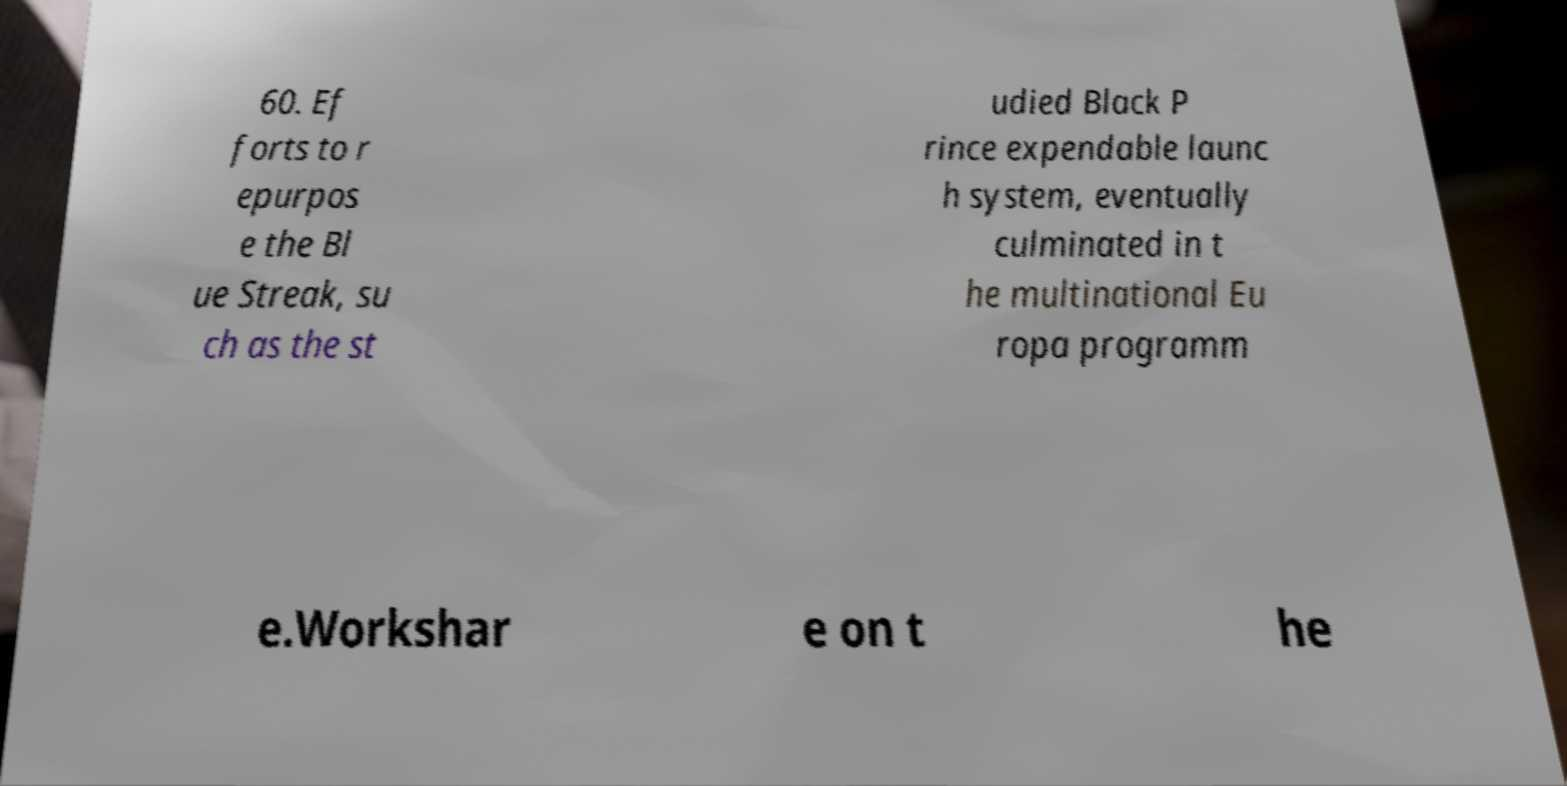What messages or text are displayed in this image? I need them in a readable, typed format. 60. Ef forts to r epurpos e the Bl ue Streak, su ch as the st udied Black P rince expendable launc h system, eventually culminated in t he multinational Eu ropa programm e.Workshar e on t he 